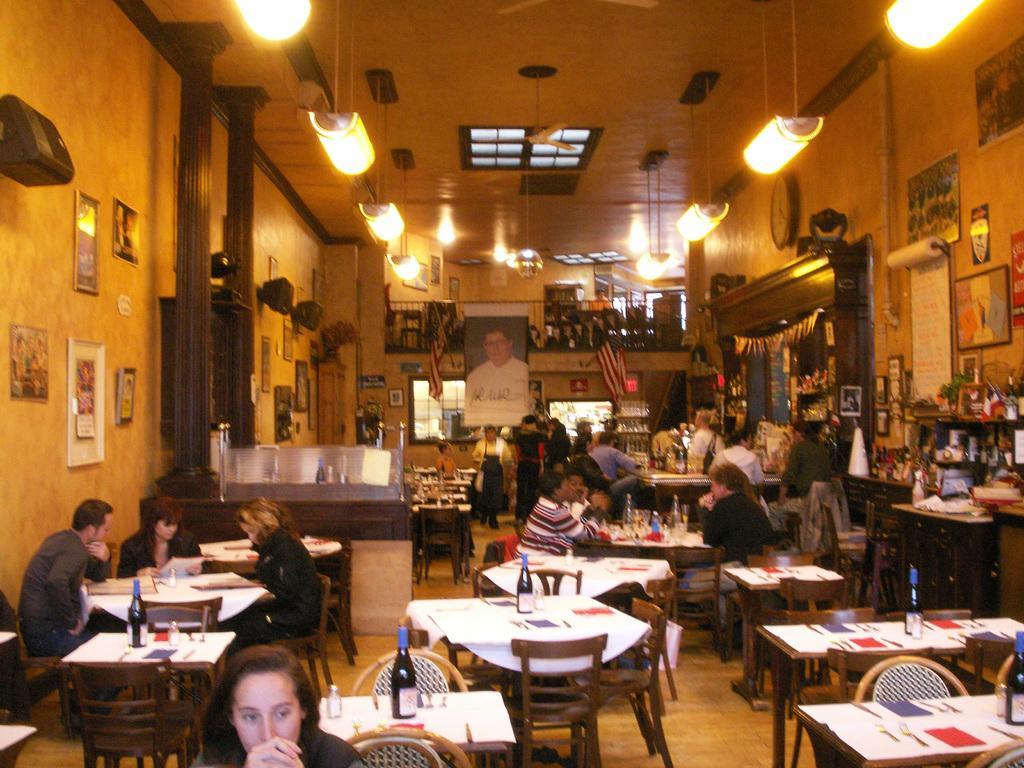Can you describe this image briefly? In A room there are many table and chairs. And many people are sitting and some are standing. To the left side wall there are five frames and a speaker and two pillars. And to the right side there are frames, posters, clock,cupboards with toys. In the middle there is a frame and flag. On the top there are lights. 